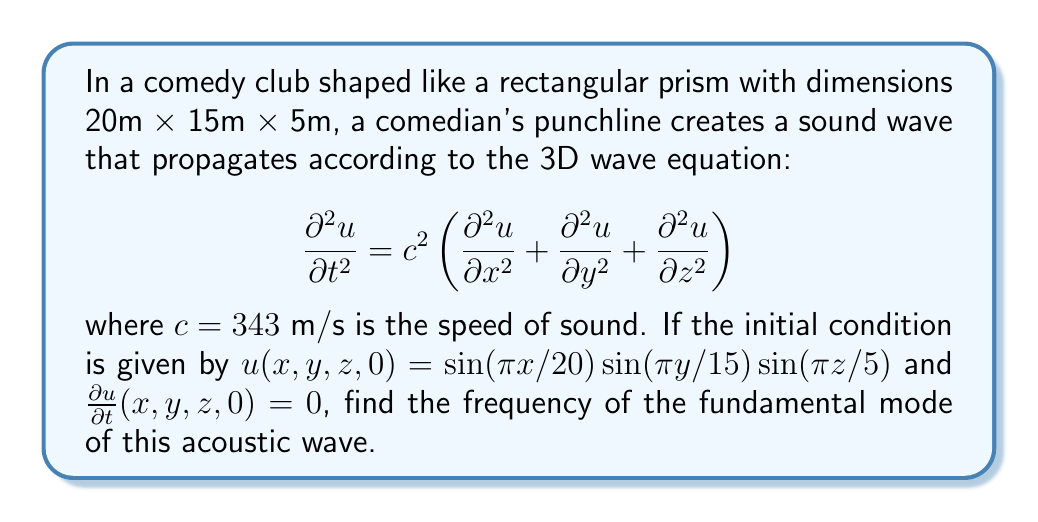Provide a solution to this math problem. Let's approach this step-by-step:

1) The general solution for the 3D wave equation with the given initial conditions is:

   $$u(x,y,z,t) = \cos(\omega t)\sin(\pi x/20)\sin(\pi y/15)\sin(\pi z/5)$$

2) Substituting this into the wave equation:

   $$-\omega^2\cos(\omega t)\sin(\pi x/20)\sin(\pi y/15)\sin(\pi z/5) = c^2\left[-(\pi/20)^2 - (\pi/15)^2 - (\pi/5)^2\right]\cos(\omega t)\sin(\pi x/20)\sin(\pi y/15)\sin(\pi z/5)$$

3) Simplifying:

   $$\omega^2 = c^2\left[(\pi/20)^2 + (\pi/15)^2 + (\pi/5)^2\right]$$

4) Substituting $c = 343$ m/s:

   $$\omega^2 = 343^2\left[(\pi/20)^2 + (\pi/15)^2 + (\pi/5)^2\right]$$

5) Calculating:

   $$\omega^2 = 343^2\left[0.0246 + 0.0438 + 0.3948\right] = 343^2 \cdot 0.4632 = 54,486.31$$

6) Taking the square root:

   $$\omega = \sqrt{54,486.31} \approx 233.42 \text{ rad/s}$$

7) Converting to frequency:

   $$f = \frac{\omega}{2\pi} \approx 37.14 \text{ Hz}$$

This is the frequency of the fundamental mode.
Answer: 37.14 Hz 